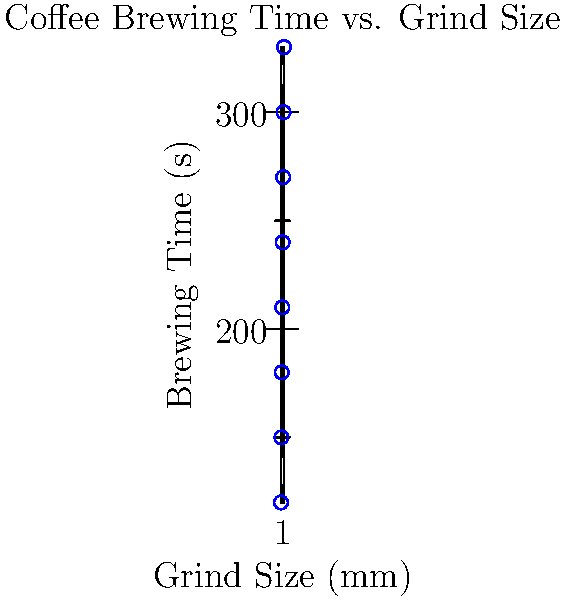Based on the scatter plot showing the relationship between coffee grind size and brewing time, what would be the estimated brewing time for a grind size of 1.1 mm? To estimate the brewing time for a grind size of 1.1 mm, we need to follow these steps:

1. Observe the trend in the scatter plot: As grind size increases, brewing time also increases.

2. Locate the position of 1.1 mm on the x-axis (between 1.0 and 1.2 mm).

3. Identify the corresponding y-values (brewing times) for 1.0 mm and 1.2 mm:
   - At 1.0 mm: approximately 240 seconds
   - At 1.2 mm: approximately 270 seconds

4. Estimate the brewing time for 1.1 mm using linear interpolation:
   $1.1 \text{ mm} = \frac{1.1 - 1.0}{1.2 - 1.0} = 0.5$ of the way between 1.0 and 1.2 mm

5. Calculate the estimated brewing time:
   $\text{Estimated time} = 240 + 0.5 * (270 - 240) = 240 + 15 = 255$ seconds

Therefore, the estimated brewing time for a grind size of 1.1 mm is approximately 255 seconds.
Answer: 255 seconds 